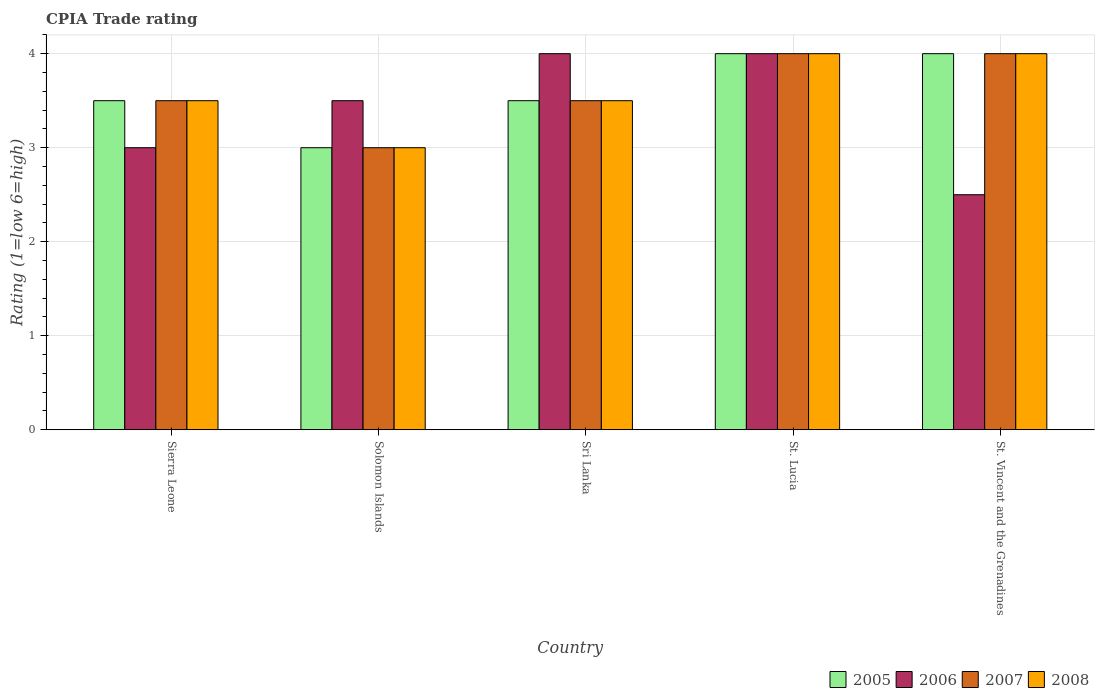Are the number of bars per tick equal to the number of legend labels?
Your answer should be very brief. Yes. Are the number of bars on each tick of the X-axis equal?
Offer a terse response. Yes. How many bars are there on the 3rd tick from the left?
Provide a succinct answer. 4. What is the label of the 5th group of bars from the left?
Offer a very short reply. St. Vincent and the Grenadines. In how many cases, is the number of bars for a given country not equal to the number of legend labels?
Your answer should be compact. 0. Across all countries, what is the maximum CPIA rating in 2008?
Offer a terse response. 4. Across all countries, what is the minimum CPIA rating in 2005?
Offer a very short reply. 3. In which country was the CPIA rating in 2007 maximum?
Keep it short and to the point. St. Lucia. In which country was the CPIA rating in 2005 minimum?
Your response must be concise. Solomon Islands. What is the difference between the CPIA rating in 2008 in Sierra Leone and that in St. Vincent and the Grenadines?
Your answer should be very brief. -0.5. What is the difference between the CPIA rating in 2008 in St. Lucia and the CPIA rating in 2007 in St. Vincent and the Grenadines?
Offer a very short reply. 0. What is the difference between the CPIA rating of/in 2005 and CPIA rating of/in 2007 in Sierra Leone?
Ensure brevity in your answer.  0. In how many countries, is the CPIA rating in 2005 greater than 1.8?
Provide a succinct answer. 5. Is the CPIA rating in 2005 in Sri Lanka less than that in St. Vincent and the Grenadines?
Ensure brevity in your answer.  Yes. What is the difference between the highest and the lowest CPIA rating in 2008?
Offer a very short reply. 1. In how many countries, is the CPIA rating in 2007 greater than the average CPIA rating in 2007 taken over all countries?
Offer a terse response. 2. Is it the case that in every country, the sum of the CPIA rating in 2007 and CPIA rating in 2005 is greater than the sum of CPIA rating in 2008 and CPIA rating in 2006?
Your answer should be compact. No. What does the 2nd bar from the left in Sierra Leone represents?
Keep it short and to the point. 2006. What does the 2nd bar from the right in Sri Lanka represents?
Your response must be concise. 2007. How many bars are there?
Your answer should be compact. 20. Are all the bars in the graph horizontal?
Your answer should be very brief. No. How many countries are there in the graph?
Offer a very short reply. 5. Are the values on the major ticks of Y-axis written in scientific E-notation?
Give a very brief answer. No. Does the graph contain any zero values?
Provide a succinct answer. No. Where does the legend appear in the graph?
Your answer should be very brief. Bottom right. How are the legend labels stacked?
Your response must be concise. Horizontal. What is the title of the graph?
Offer a very short reply. CPIA Trade rating. Does "1971" appear as one of the legend labels in the graph?
Your response must be concise. No. What is the label or title of the X-axis?
Ensure brevity in your answer.  Country. What is the Rating (1=low 6=high) in 2005 in Sierra Leone?
Provide a short and direct response. 3.5. What is the Rating (1=low 6=high) in 2007 in Sierra Leone?
Your response must be concise. 3.5. What is the Rating (1=low 6=high) in 2008 in Sierra Leone?
Provide a succinct answer. 3.5. What is the Rating (1=low 6=high) of 2007 in Solomon Islands?
Provide a succinct answer. 3. What is the Rating (1=low 6=high) in 2008 in Solomon Islands?
Your response must be concise. 3. What is the Rating (1=low 6=high) in 2008 in Sri Lanka?
Offer a terse response. 3.5. What is the Rating (1=low 6=high) in 2006 in St. Vincent and the Grenadines?
Offer a very short reply. 2.5. Across all countries, what is the maximum Rating (1=low 6=high) in 2005?
Ensure brevity in your answer.  4. Across all countries, what is the maximum Rating (1=low 6=high) in 2006?
Your response must be concise. 4. Across all countries, what is the maximum Rating (1=low 6=high) of 2008?
Keep it short and to the point. 4. Across all countries, what is the minimum Rating (1=low 6=high) in 2006?
Your answer should be compact. 2.5. Across all countries, what is the minimum Rating (1=low 6=high) of 2007?
Keep it short and to the point. 3. What is the total Rating (1=low 6=high) in 2005 in the graph?
Your response must be concise. 18. What is the total Rating (1=low 6=high) of 2006 in the graph?
Your response must be concise. 17. What is the total Rating (1=low 6=high) in 2007 in the graph?
Your answer should be compact. 18. What is the total Rating (1=low 6=high) in 2008 in the graph?
Offer a terse response. 18. What is the difference between the Rating (1=low 6=high) of 2007 in Sierra Leone and that in Sri Lanka?
Offer a terse response. 0. What is the difference between the Rating (1=low 6=high) in 2008 in Sierra Leone and that in Sri Lanka?
Provide a short and direct response. 0. What is the difference between the Rating (1=low 6=high) of 2005 in Sierra Leone and that in St. Lucia?
Your answer should be compact. -0.5. What is the difference between the Rating (1=low 6=high) of 2007 in Sierra Leone and that in St. Lucia?
Ensure brevity in your answer.  -0.5. What is the difference between the Rating (1=low 6=high) in 2005 in Sierra Leone and that in St. Vincent and the Grenadines?
Your answer should be very brief. -0.5. What is the difference between the Rating (1=low 6=high) in 2006 in Solomon Islands and that in Sri Lanka?
Ensure brevity in your answer.  -0.5. What is the difference between the Rating (1=low 6=high) in 2008 in Solomon Islands and that in Sri Lanka?
Make the answer very short. -0.5. What is the difference between the Rating (1=low 6=high) of 2007 in Solomon Islands and that in St. Lucia?
Give a very brief answer. -1. What is the difference between the Rating (1=low 6=high) in 2008 in Solomon Islands and that in St. Lucia?
Offer a very short reply. -1. What is the difference between the Rating (1=low 6=high) in 2006 in Solomon Islands and that in St. Vincent and the Grenadines?
Your answer should be compact. 1. What is the difference between the Rating (1=low 6=high) of 2007 in Solomon Islands and that in St. Vincent and the Grenadines?
Make the answer very short. -1. What is the difference between the Rating (1=low 6=high) of 2008 in Solomon Islands and that in St. Vincent and the Grenadines?
Provide a succinct answer. -1. What is the difference between the Rating (1=low 6=high) of 2006 in Sri Lanka and that in St. Lucia?
Ensure brevity in your answer.  0. What is the difference between the Rating (1=low 6=high) in 2008 in Sri Lanka and that in St. Lucia?
Keep it short and to the point. -0.5. What is the difference between the Rating (1=low 6=high) in 2005 in Sri Lanka and that in St. Vincent and the Grenadines?
Make the answer very short. -0.5. What is the difference between the Rating (1=low 6=high) in 2006 in Sri Lanka and that in St. Vincent and the Grenadines?
Give a very brief answer. 1.5. What is the difference between the Rating (1=low 6=high) in 2007 in Sri Lanka and that in St. Vincent and the Grenadines?
Provide a short and direct response. -0.5. What is the difference between the Rating (1=low 6=high) in 2005 in St. Lucia and that in St. Vincent and the Grenadines?
Provide a short and direct response. 0. What is the difference between the Rating (1=low 6=high) of 2006 in St. Lucia and that in St. Vincent and the Grenadines?
Offer a terse response. 1.5. What is the difference between the Rating (1=low 6=high) in 2008 in St. Lucia and that in St. Vincent and the Grenadines?
Your answer should be very brief. 0. What is the difference between the Rating (1=low 6=high) in 2005 in Sierra Leone and the Rating (1=low 6=high) in 2008 in Solomon Islands?
Your answer should be compact. 0.5. What is the difference between the Rating (1=low 6=high) of 2006 in Sierra Leone and the Rating (1=low 6=high) of 2007 in Solomon Islands?
Make the answer very short. 0. What is the difference between the Rating (1=low 6=high) in 2006 in Sierra Leone and the Rating (1=low 6=high) in 2008 in Solomon Islands?
Your answer should be compact. 0. What is the difference between the Rating (1=low 6=high) of 2006 in Sierra Leone and the Rating (1=low 6=high) of 2007 in Sri Lanka?
Your answer should be compact. -0.5. What is the difference between the Rating (1=low 6=high) of 2006 in Sierra Leone and the Rating (1=low 6=high) of 2008 in Sri Lanka?
Your response must be concise. -0.5. What is the difference between the Rating (1=low 6=high) of 2005 in Sierra Leone and the Rating (1=low 6=high) of 2007 in St. Lucia?
Provide a short and direct response. -0.5. What is the difference between the Rating (1=low 6=high) of 2005 in Sierra Leone and the Rating (1=low 6=high) of 2008 in St. Lucia?
Your answer should be compact. -0.5. What is the difference between the Rating (1=low 6=high) in 2005 in Sierra Leone and the Rating (1=low 6=high) in 2006 in St. Vincent and the Grenadines?
Your answer should be very brief. 1. What is the difference between the Rating (1=low 6=high) in 2005 in Sierra Leone and the Rating (1=low 6=high) in 2008 in St. Vincent and the Grenadines?
Offer a terse response. -0.5. What is the difference between the Rating (1=low 6=high) of 2006 in Sierra Leone and the Rating (1=low 6=high) of 2007 in St. Vincent and the Grenadines?
Make the answer very short. -1. What is the difference between the Rating (1=low 6=high) in 2007 in Sierra Leone and the Rating (1=low 6=high) in 2008 in St. Vincent and the Grenadines?
Provide a short and direct response. -0.5. What is the difference between the Rating (1=low 6=high) in 2005 in Solomon Islands and the Rating (1=low 6=high) in 2006 in Sri Lanka?
Your response must be concise. -1. What is the difference between the Rating (1=low 6=high) of 2005 in Solomon Islands and the Rating (1=low 6=high) of 2008 in Sri Lanka?
Make the answer very short. -0.5. What is the difference between the Rating (1=low 6=high) in 2006 in Solomon Islands and the Rating (1=low 6=high) in 2007 in Sri Lanka?
Ensure brevity in your answer.  0. What is the difference between the Rating (1=low 6=high) of 2006 in Solomon Islands and the Rating (1=low 6=high) of 2008 in Sri Lanka?
Provide a short and direct response. 0. What is the difference between the Rating (1=low 6=high) in 2007 in Solomon Islands and the Rating (1=low 6=high) in 2008 in Sri Lanka?
Your answer should be very brief. -0.5. What is the difference between the Rating (1=low 6=high) of 2005 in Solomon Islands and the Rating (1=low 6=high) of 2007 in St. Lucia?
Offer a terse response. -1. What is the difference between the Rating (1=low 6=high) in 2005 in Solomon Islands and the Rating (1=low 6=high) in 2008 in St. Lucia?
Your answer should be compact. -1. What is the difference between the Rating (1=low 6=high) of 2006 in Solomon Islands and the Rating (1=low 6=high) of 2007 in St. Lucia?
Offer a terse response. -0.5. What is the difference between the Rating (1=low 6=high) in 2005 in Solomon Islands and the Rating (1=low 6=high) in 2006 in St. Vincent and the Grenadines?
Provide a succinct answer. 0.5. What is the difference between the Rating (1=low 6=high) of 2006 in Solomon Islands and the Rating (1=low 6=high) of 2007 in St. Vincent and the Grenadines?
Ensure brevity in your answer.  -0.5. What is the difference between the Rating (1=low 6=high) in 2006 in Solomon Islands and the Rating (1=low 6=high) in 2008 in St. Vincent and the Grenadines?
Ensure brevity in your answer.  -0.5. What is the difference between the Rating (1=low 6=high) in 2005 in Sri Lanka and the Rating (1=low 6=high) in 2006 in St. Lucia?
Your answer should be very brief. -0.5. What is the difference between the Rating (1=low 6=high) of 2005 in Sri Lanka and the Rating (1=low 6=high) of 2008 in St. Lucia?
Make the answer very short. -0.5. What is the difference between the Rating (1=low 6=high) in 2006 in Sri Lanka and the Rating (1=low 6=high) in 2007 in St. Lucia?
Offer a very short reply. 0. What is the difference between the Rating (1=low 6=high) of 2005 in Sri Lanka and the Rating (1=low 6=high) of 2006 in St. Vincent and the Grenadines?
Provide a short and direct response. 1. What is the difference between the Rating (1=low 6=high) of 2005 in Sri Lanka and the Rating (1=low 6=high) of 2008 in St. Vincent and the Grenadines?
Your answer should be very brief. -0.5. What is the difference between the Rating (1=low 6=high) of 2007 in Sri Lanka and the Rating (1=low 6=high) of 2008 in St. Vincent and the Grenadines?
Ensure brevity in your answer.  -0.5. What is the difference between the Rating (1=low 6=high) of 2005 in St. Lucia and the Rating (1=low 6=high) of 2006 in St. Vincent and the Grenadines?
Your response must be concise. 1.5. What is the difference between the Rating (1=low 6=high) of 2005 in St. Lucia and the Rating (1=low 6=high) of 2007 in St. Vincent and the Grenadines?
Make the answer very short. 0. What is the difference between the Rating (1=low 6=high) of 2005 in St. Lucia and the Rating (1=low 6=high) of 2008 in St. Vincent and the Grenadines?
Give a very brief answer. 0. What is the difference between the Rating (1=low 6=high) in 2006 in St. Lucia and the Rating (1=low 6=high) in 2007 in St. Vincent and the Grenadines?
Offer a very short reply. 0. What is the difference between the Rating (1=low 6=high) of 2007 in St. Lucia and the Rating (1=low 6=high) of 2008 in St. Vincent and the Grenadines?
Offer a terse response. 0. What is the average Rating (1=low 6=high) of 2005 per country?
Make the answer very short. 3.6. What is the average Rating (1=low 6=high) of 2006 per country?
Give a very brief answer. 3.4. What is the average Rating (1=low 6=high) in 2007 per country?
Ensure brevity in your answer.  3.6. What is the average Rating (1=low 6=high) in 2008 per country?
Give a very brief answer. 3.6. What is the difference between the Rating (1=low 6=high) in 2005 and Rating (1=low 6=high) in 2006 in Sierra Leone?
Offer a very short reply. 0.5. What is the difference between the Rating (1=low 6=high) in 2006 and Rating (1=low 6=high) in 2007 in Sierra Leone?
Ensure brevity in your answer.  -0.5. What is the difference between the Rating (1=low 6=high) in 2006 and Rating (1=low 6=high) in 2008 in Sierra Leone?
Offer a very short reply. -0.5. What is the difference between the Rating (1=low 6=high) of 2005 and Rating (1=low 6=high) of 2007 in Solomon Islands?
Your answer should be very brief. 0. What is the difference between the Rating (1=low 6=high) of 2006 and Rating (1=low 6=high) of 2008 in Solomon Islands?
Your answer should be very brief. 0.5. What is the difference between the Rating (1=low 6=high) of 2005 and Rating (1=low 6=high) of 2007 in Sri Lanka?
Keep it short and to the point. 0. What is the difference between the Rating (1=low 6=high) of 2006 and Rating (1=low 6=high) of 2007 in Sri Lanka?
Offer a very short reply. 0.5. What is the difference between the Rating (1=low 6=high) in 2006 and Rating (1=low 6=high) in 2008 in Sri Lanka?
Your answer should be compact. 0.5. What is the difference between the Rating (1=low 6=high) of 2007 and Rating (1=low 6=high) of 2008 in Sri Lanka?
Provide a short and direct response. 0. What is the difference between the Rating (1=low 6=high) in 2005 and Rating (1=low 6=high) in 2008 in St. Lucia?
Make the answer very short. 0. What is the difference between the Rating (1=low 6=high) of 2006 and Rating (1=low 6=high) of 2008 in St. Lucia?
Your response must be concise. 0. What is the difference between the Rating (1=low 6=high) of 2005 and Rating (1=low 6=high) of 2006 in St. Vincent and the Grenadines?
Ensure brevity in your answer.  1.5. What is the difference between the Rating (1=low 6=high) of 2006 and Rating (1=low 6=high) of 2008 in St. Vincent and the Grenadines?
Your response must be concise. -1.5. What is the ratio of the Rating (1=low 6=high) in 2005 in Sierra Leone to that in Solomon Islands?
Provide a short and direct response. 1.17. What is the ratio of the Rating (1=low 6=high) of 2006 in Sierra Leone to that in Solomon Islands?
Your answer should be compact. 0.86. What is the ratio of the Rating (1=low 6=high) of 2005 in Sierra Leone to that in Sri Lanka?
Provide a short and direct response. 1. What is the ratio of the Rating (1=low 6=high) of 2006 in Sierra Leone to that in Sri Lanka?
Provide a succinct answer. 0.75. What is the ratio of the Rating (1=low 6=high) of 2007 in Sierra Leone to that in St. Lucia?
Your answer should be compact. 0.88. What is the ratio of the Rating (1=low 6=high) of 2005 in Sierra Leone to that in St. Vincent and the Grenadines?
Ensure brevity in your answer.  0.88. What is the ratio of the Rating (1=low 6=high) of 2006 in Sierra Leone to that in St. Vincent and the Grenadines?
Your answer should be very brief. 1.2. What is the ratio of the Rating (1=low 6=high) of 2007 in Sierra Leone to that in St. Vincent and the Grenadines?
Make the answer very short. 0.88. What is the ratio of the Rating (1=low 6=high) of 2008 in Sierra Leone to that in St. Vincent and the Grenadines?
Make the answer very short. 0.88. What is the ratio of the Rating (1=low 6=high) in 2008 in Solomon Islands to that in Sri Lanka?
Ensure brevity in your answer.  0.86. What is the ratio of the Rating (1=low 6=high) of 2005 in Solomon Islands to that in St. Lucia?
Make the answer very short. 0.75. What is the ratio of the Rating (1=low 6=high) in 2006 in Solomon Islands to that in St. Lucia?
Give a very brief answer. 0.88. What is the ratio of the Rating (1=low 6=high) of 2008 in Solomon Islands to that in St. Lucia?
Offer a terse response. 0.75. What is the ratio of the Rating (1=low 6=high) of 2005 in Solomon Islands to that in St. Vincent and the Grenadines?
Offer a very short reply. 0.75. What is the ratio of the Rating (1=low 6=high) of 2006 in Solomon Islands to that in St. Vincent and the Grenadines?
Give a very brief answer. 1.4. What is the ratio of the Rating (1=low 6=high) of 2006 in Sri Lanka to that in St. Lucia?
Give a very brief answer. 1. What is the ratio of the Rating (1=low 6=high) of 2007 in Sri Lanka to that in St. Lucia?
Ensure brevity in your answer.  0.88. What is the ratio of the Rating (1=low 6=high) in 2008 in Sri Lanka to that in St. Lucia?
Your answer should be very brief. 0.88. What is the ratio of the Rating (1=low 6=high) in 2005 in Sri Lanka to that in St. Vincent and the Grenadines?
Give a very brief answer. 0.88. What is the ratio of the Rating (1=low 6=high) of 2006 in Sri Lanka to that in St. Vincent and the Grenadines?
Provide a short and direct response. 1.6. What is the ratio of the Rating (1=low 6=high) of 2007 in Sri Lanka to that in St. Vincent and the Grenadines?
Offer a terse response. 0.88. What is the ratio of the Rating (1=low 6=high) in 2005 in St. Lucia to that in St. Vincent and the Grenadines?
Your answer should be compact. 1. What is the ratio of the Rating (1=low 6=high) in 2006 in St. Lucia to that in St. Vincent and the Grenadines?
Your answer should be very brief. 1.6. What is the ratio of the Rating (1=low 6=high) in 2008 in St. Lucia to that in St. Vincent and the Grenadines?
Offer a very short reply. 1. What is the difference between the highest and the second highest Rating (1=low 6=high) of 2005?
Provide a succinct answer. 0. What is the difference between the highest and the second highest Rating (1=low 6=high) in 2007?
Provide a short and direct response. 0. What is the difference between the highest and the second highest Rating (1=low 6=high) of 2008?
Offer a terse response. 0. What is the difference between the highest and the lowest Rating (1=low 6=high) in 2005?
Your answer should be compact. 1. What is the difference between the highest and the lowest Rating (1=low 6=high) in 2006?
Your answer should be compact. 1.5. What is the difference between the highest and the lowest Rating (1=low 6=high) of 2007?
Keep it short and to the point. 1. What is the difference between the highest and the lowest Rating (1=low 6=high) of 2008?
Offer a terse response. 1. 